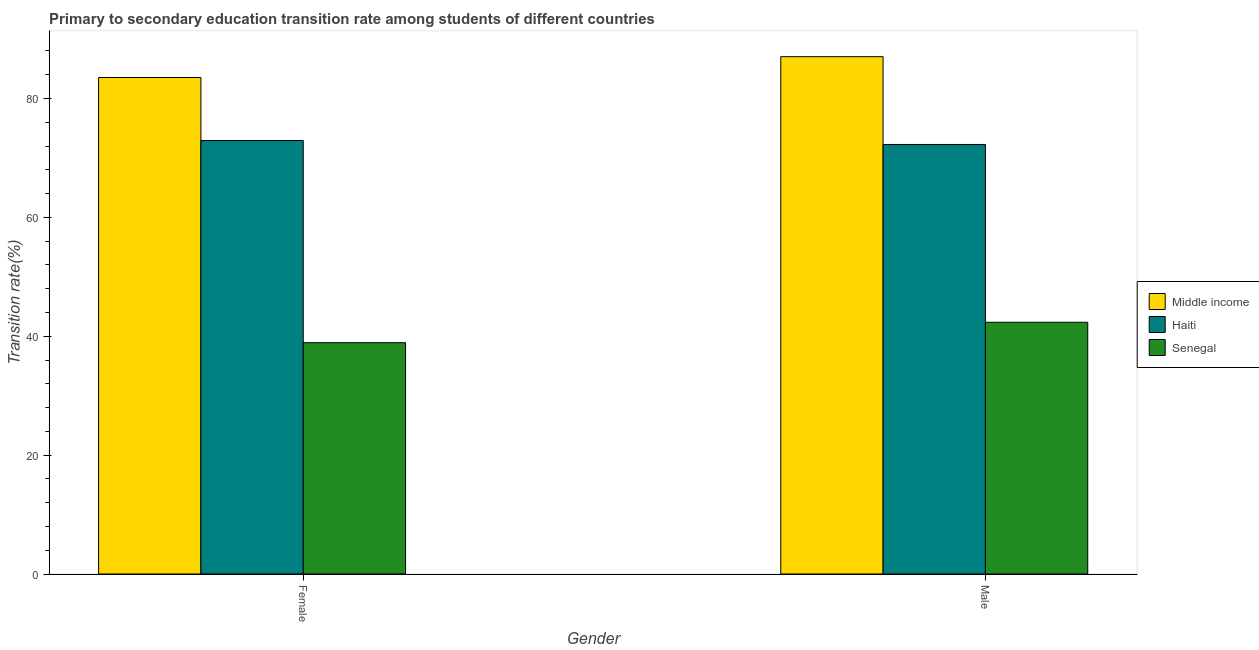Are the number of bars on each tick of the X-axis equal?
Ensure brevity in your answer.  Yes. How many bars are there on the 2nd tick from the left?
Provide a short and direct response. 3. How many bars are there on the 1st tick from the right?
Make the answer very short. 3. What is the label of the 2nd group of bars from the left?
Give a very brief answer. Male. What is the transition rate among male students in Middle income?
Your answer should be very brief. 87.03. Across all countries, what is the maximum transition rate among male students?
Your answer should be very brief. 87.03. Across all countries, what is the minimum transition rate among female students?
Give a very brief answer. 38.91. In which country was the transition rate among male students maximum?
Give a very brief answer. Middle income. In which country was the transition rate among female students minimum?
Make the answer very short. Senegal. What is the total transition rate among male students in the graph?
Keep it short and to the point. 201.63. What is the difference between the transition rate among male students in Haiti and that in Middle income?
Make the answer very short. -14.77. What is the difference between the transition rate among male students in Middle income and the transition rate among female students in Senegal?
Your answer should be very brief. 48.11. What is the average transition rate among female students per country?
Your response must be concise. 65.12. What is the difference between the transition rate among female students and transition rate among male students in Haiti?
Your answer should be very brief. 0.67. In how many countries, is the transition rate among male students greater than 36 %?
Offer a very short reply. 3. What is the ratio of the transition rate among male students in Senegal to that in Haiti?
Keep it short and to the point. 0.59. Is the transition rate among female students in Haiti less than that in Senegal?
Ensure brevity in your answer.  No. What does the 3rd bar from the left in Male represents?
Your response must be concise. Senegal. What does the 1st bar from the right in Male represents?
Make the answer very short. Senegal. How many bars are there?
Make the answer very short. 6. How many countries are there in the graph?
Keep it short and to the point. 3. Are the values on the major ticks of Y-axis written in scientific E-notation?
Offer a very short reply. No. Does the graph contain any zero values?
Ensure brevity in your answer.  No. How many legend labels are there?
Your response must be concise. 3. What is the title of the graph?
Your response must be concise. Primary to secondary education transition rate among students of different countries. Does "Malta" appear as one of the legend labels in the graph?
Offer a very short reply. No. What is the label or title of the X-axis?
Provide a succinct answer. Gender. What is the label or title of the Y-axis?
Your response must be concise. Transition rate(%). What is the Transition rate(%) in Middle income in Female?
Your response must be concise. 83.52. What is the Transition rate(%) in Haiti in Female?
Your response must be concise. 72.93. What is the Transition rate(%) of Senegal in Female?
Provide a short and direct response. 38.91. What is the Transition rate(%) of Middle income in Male?
Give a very brief answer. 87.03. What is the Transition rate(%) in Haiti in Male?
Your answer should be compact. 72.26. What is the Transition rate(%) in Senegal in Male?
Your response must be concise. 42.35. Across all Gender, what is the maximum Transition rate(%) of Middle income?
Offer a very short reply. 87.03. Across all Gender, what is the maximum Transition rate(%) of Haiti?
Ensure brevity in your answer.  72.93. Across all Gender, what is the maximum Transition rate(%) of Senegal?
Your response must be concise. 42.35. Across all Gender, what is the minimum Transition rate(%) in Middle income?
Make the answer very short. 83.52. Across all Gender, what is the minimum Transition rate(%) in Haiti?
Ensure brevity in your answer.  72.26. Across all Gender, what is the minimum Transition rate(%) in Senegal?
Make the answer very short. 38.91. What is the total Transition rate(%) in Middle income in the graph?
Offer a terse response. 170.55. What is the total Transition rate(%) in Haiti in the graph?
Your response must be concise. 145.18. What is the total Transition rate(%) in Senegal in the graph?
Offer a terse response. 81.26. What is the difference between the Transition rate(%) in Middle income in Female and that in Male?
Offer a terse response. -3.5. What is the difference between the Transition rate(%) in Haiti in Female and that in Male?
Your answer should be compact. 0.67. What is the difference between the Transition rate(%) of Senegal in Female and that in Male?
Offer a terse response. -3.43. What is the difference between the Transition rate(%) in Middle income in Female and the Transition rate(%) in Haiti in Male?
Give a very brief answer. 11.27. What is the difference between the Transition rate(%) in Middle income in Female and the Transition rate(%) in Senegal in Male?
Ensure brevity in your answer.  41.18. What is the difference between the Transition rate(%) in Haiti in Female and the Transition rate(%) in Senegal in Male?
Your response must be concise. 30.58. What is the average Transition rate(%) in Middle income per Gender?
Provide a short and direct response. 85.27. What is the average Transition rate(%) of Haiti per Gender?
Your answer should be very brief. 72.59. What is the average Transition rate(%) in Senegal per Gender?
Your response must be concise. 40.63. What is the difference between the Transition rate(%) in Middle income and Transition rate(%) in Haiti in Female?
Your answer should be very brief. 10.6. What is the difference between the Transition rate(%) in Middle income and Transition rate(%) in Senegal in Female?
Keep it short and to the point. 44.61. What is the difference between the Transition rate(%) of Haiti and Transition rate(%) of Senegal in Female?
Your response must be concise. 34.01. What is the difference between the Transition rate(%) in Middle income and Transition rate(%) in Haiti in Male?
Your answer should be compact. 14.77. What is the difference between the Transition rate(%) in Middle income and Transition rate(%) in Senegal in Male?
Ensure brevity in your answer.  44.68. What is the difference between the Transition rate(%) in Haiti and Transition rate(%) in Senegal in Male?
Ensure brevity in your answer.  29.91. What is the ratio of the Transition rate(%) of Middle income in Female to that in Male?
Your response must be concise. 0.96. What is the ratio of the Transition rate(%) of Haiti in Female to that in Male?
Give a very brief answer. 1.01. What is the ratio of the Transition rate(%) in Senegal in Female to that in Male?
Ensure brevity in your answer.  0.92. What is the difference between the highest and the second highest Transition rate(%) of Middle income?
Your answer should be compact. 3.5. What is the difference between the highest and the second highest Transition rate(%) in Haiti?
Keep it short and to the point. 0.67. What is the difference between the highest and the second highest Transition rate(%) in Senegal?
Ensure brevity in your answer.  3.43. What is the difference between the highest and the lowest Transition rate(%) in Middle income?
Ensure brevity in your answer.  3.5. What is the difference between the highest and the lowest Transition rate(%) of Haiti?
Make the answer very short. 0.67. What is the difference between the highest and the lowest Transition rate(%) of Senegal?
Offer a terse response. 3.43. 